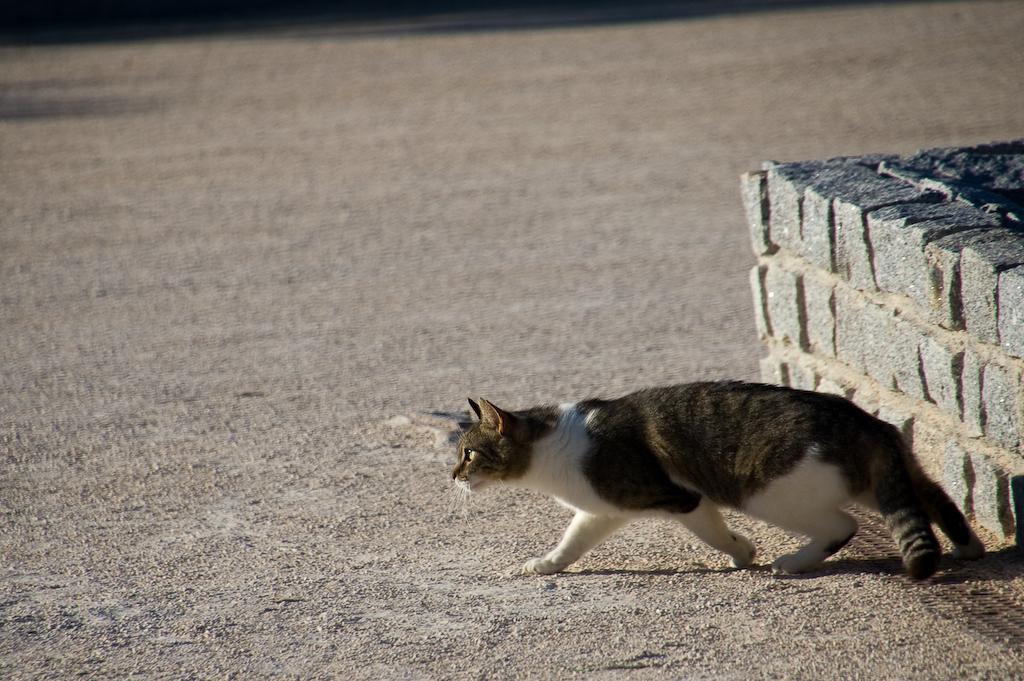How would you summarize this image in a sentence or two? On the right side of the image, there is a wall. In the center of the image, we can see one cat, which is brown and white color. In the background, we can see it is blurred. 